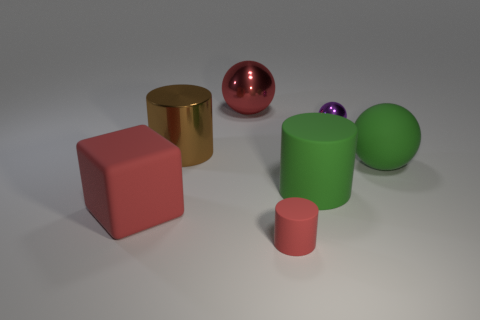Add 2 red balls. How many objects exist? 9 Subtract all cylinders. How many objects are left? 4 Add 3 purple metallic things. How many purple metallic things are left? 4 Add 4 big blocks. How many big blocks exist? 5 Subtract 0 purple cylinders. How many objects are left? 7 Subtract all brown things. Subtract all brown cylinders. How many objects are left? 5 